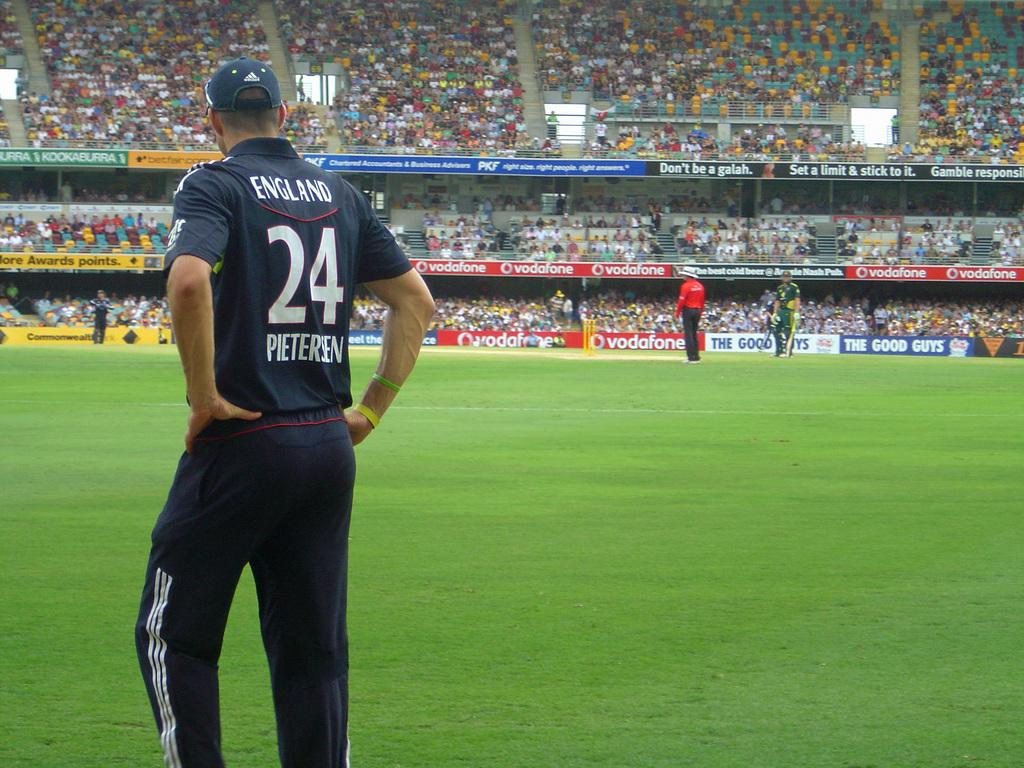Provide a one-sentence caption for the provided image. A player for England named Pieteren is standing on a soccer field. 